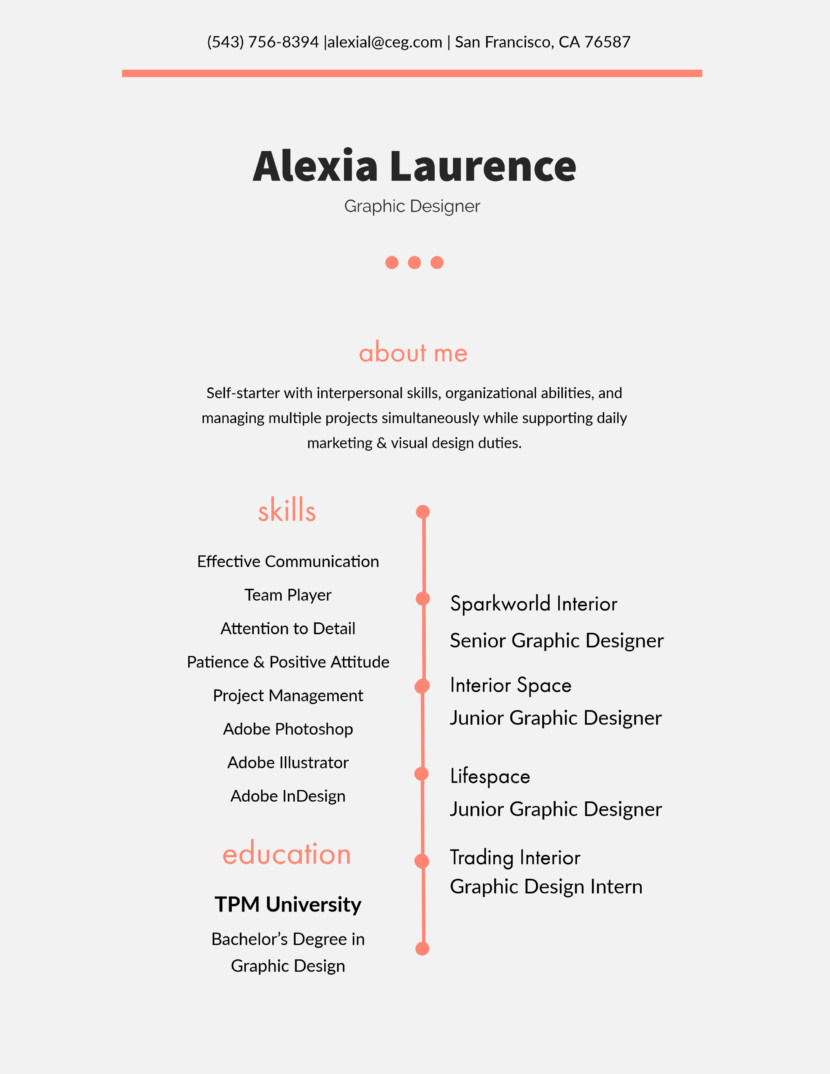Considering Alexia's listed experience and skills, which specific project or task mentioned in the resume would likely have been the most challenging for her, and why? While Alexia's resume doesn't detail specific projects, her transition to Senior Graphic Designer at Sparkworld Interior likely presented significant challenges. This role, detailed as her most recent, suggests an escalation in responsibilities, requiring advanced project management, and leadership skills beyond her earlier roles. This position would have demanded a deeper engagement with complex design projects, and more direct interactions with clients, especially in a senior capacity where expectations are notably higher. 